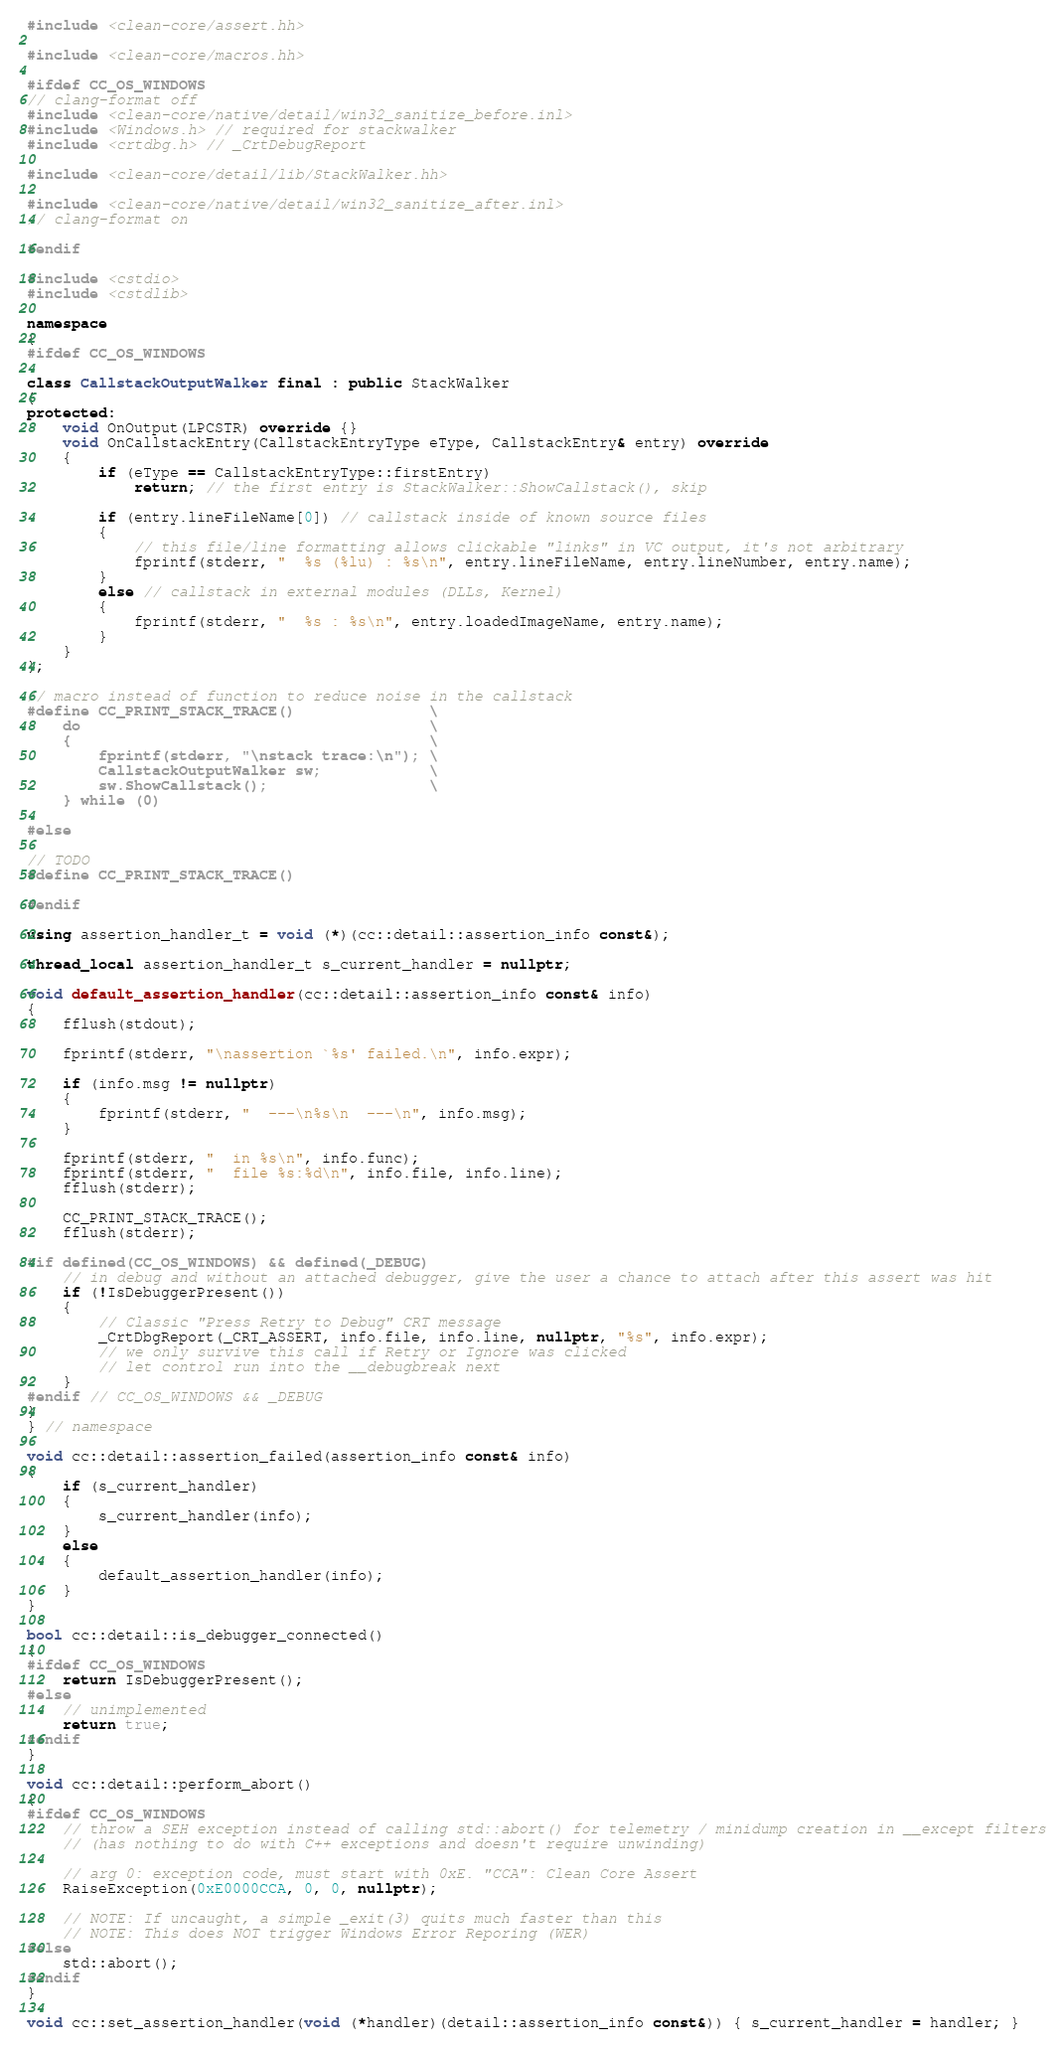<code> <loc_0><loc_0><loc_500><loc_500><_C++_>#include <clean-core/assert.hh>

#include <clean-core/macros.hh>

#ifdef CC_OS_WINDOWS
// clang-format off
#include <clean-core/native/detail/win32_sanitize_before.inl>
#include <Windows.h> // required for stackwalker
#include <crtdbg.h> // _CrtDebugReport

#include <clean-core/detail/lib/StackWalker.hh>

#include <clean-core/native/detail/win32_sanitize_after.inl>
// clang-format on

#endif

#include <cstdio>
#include <cstdlib>

namespace
{
#ifdef CC_OS_WINDOWS

class CallstackOutputWalker final : public StackWalker
{
protected:
    void OnOutput(LPCSTR) override {}
    void OnCallstackEntry(CallstackEntryType eType, CallstackEntry& entry) override
    {
        if (eType == CallstackEntryType::firstEntry)
            return; // the first entry is StackWalker::ShowCallstack(), skip

        if (entry.lineFileName[0]) // callstack inside of known source files
        {
            // this file/line formatting allows clickable "links" in VC output, it's not arbitrary
            fprintf(stderr, "  %s (%lu) : %s\n", entry.lineFileName, entry.lineNumber, entry.name);
        }
        else // callstack in external modules (DLLs, Kernel)
        {
            fprintf(stderr, "  %s : %s\n", entry.loadedImageName, entry.name);
        }
    }
};

// macro instead of function to reduce noise in the callstack
#define CC_PRINT_STACK_TRACE()               \
    do                                       \
    {                                        \
        fprintf(stderr, "\nstack trace:\n"); \
        CallstackOutputWalker sw;            \
        sw.ShowCallstack();                  \
    } while (0)

#else

// TODO
#define CC_PRINT_STACK_TRACE()

#endif

using assertion_handler_t = void (*)(cc::detail::assertion_info const&);

thread_local assertion_handler_t s_current_handler = nullptr;

void default_assertion_handler(cc::detail::assertion_info const& info)
{
    fflush(stdout);

    fprintf(stderr, "\nassertion `%s' failed.\n", info.expr);

    if (info.msg != nullptr)
    {
        fprintf(stderr, "  ---\n%s\n  ---\n", info.msg);
    }

    fprintf(stderr, "  in %s\n", info.func);
    fprintf(stderr, "  file %s:%d\n", info.file, info.line);
    fflush(stderr);

    CC_PRINT_STACK_TRACE();
    fflush(stderr);

#if defined(CC_OS_WINDOWS) && defined(_DEBUG)
    // in debug and without an attached debugger, give the user a chance to attach after this assert was hit
    if (!IsDebuggerPresent())
    {
        // Classic "Press Retry to Debug" CRT message
        _CrtDbgReport(_CRT_ASSERT, info.file, info.line, nullptr, "%s", info.expr);
        // we only survive this call if Retry or Ignore was clicked
        // let control run into the __debugbreak next
    }
#endif // CC_OS_WINDOWS && _DEBUG
}
} // namespace

void cc::detail::assertion_failed(assertion_info const& info)
{
    if (s_current_handler)
    {
        s_current_handler(info);
    }
    else
    {
        default_assertion_handler(info);
    }
}

bool cc::detail::is_debugger_connected()
{
#ifdef CC_OS_WINDOWS
    return IsDebuggerPresent();
#else
    // unimplemented
    return true;
#endif
}

void cc::detail::perform_abort()
{
#ifdef CC_OS_WINDOWS
    // throw a SEH exception instead of calling std::abort() for telemetry / minidump creation in __except filters
    // (has nothing to do with C++ exceptions and doesn't require unwinding)

    // arg 0: exception code, must start with 0xE. "CCA": Clean Core Assert
    RaiseException(0xE0000CCA, 0, 0, nullptr);

    // NOTE: If uncaught, a simple _exit(3) quits much faster than this
    // NOTE: This does NOT trigger Windows Error Reporing (WER)
#else
    std::abort();
#endif
}

void cc::set_assertion_handler(void (*handler)(detail::assertion_info const&)) { s_current_handler = handler; }
</code> 